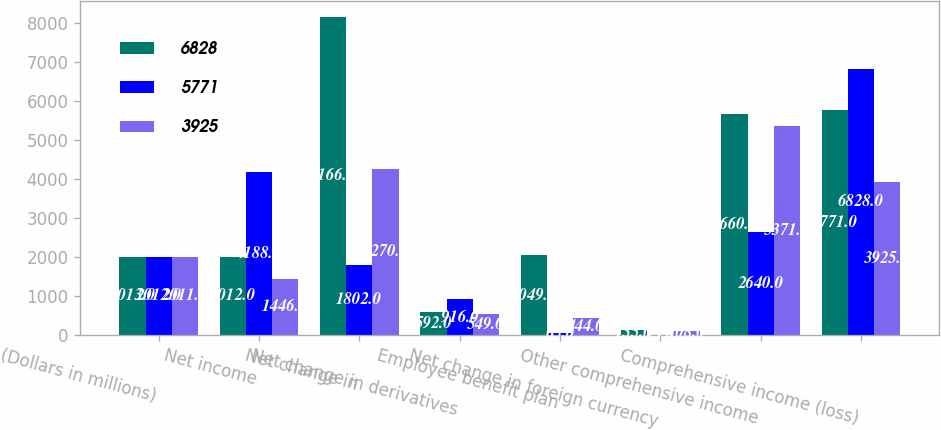Convert chart to OTSL. <chart><loc_0><loc_0><loc_500><loc_500><stacked_bar_chart><ecel><fcel>(Dollars in millions)<fcel>Net income<fcel>Net change in<fcel>Net change in derivatives<fcel>Employee benefit plan<fcel>Net change in foreign currency<fcel>Other comprehensive income<fcel>Comprehensive income (loss)<nl><fcel>6828<fcel>2013<fcel>2012<fcel>8166<fcel>592<fcel>2049<fcel>135<fcel>5660<fcel>5771<nl><fcel>5771<fcel>2012<fcel>4188<fcel>1802<fcel>916<fcel>65<fcel>13<fcel>2640<fcel>6828<nl><fcel>3925<fcel>2011<fcel>1446<fcel>4270<fcel>549<fcel>444<fcel>108<fcel>5371<fcel>3925<nl></chart> 